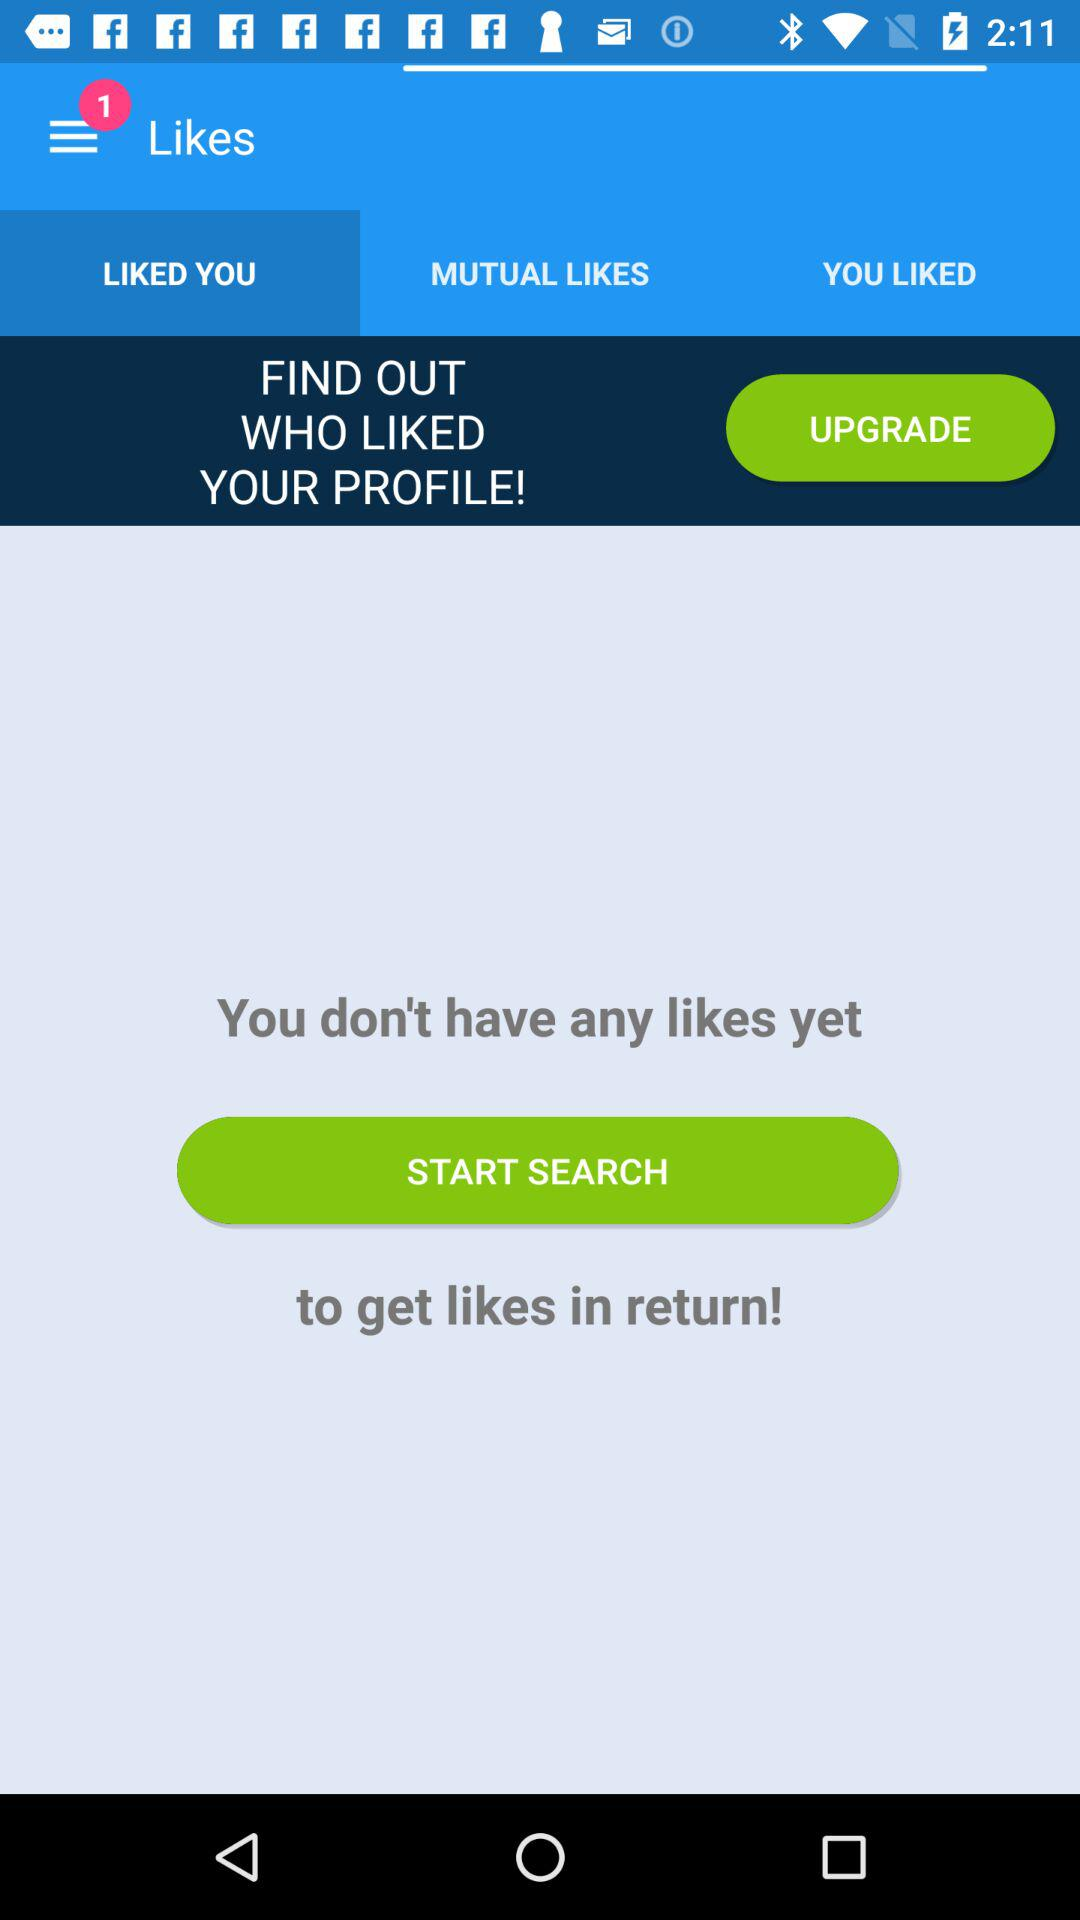How many notifications are in the menu bar? There is 1 notification. 